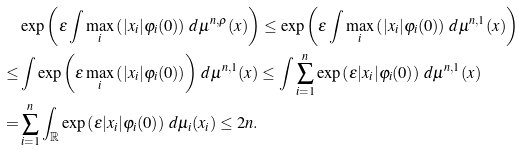Convert formula to latex. <formula><loc_0><loc_0><loc_500><loc_500>& \exp \left ( \varepsilon \int \max _ { i } \left ( | x _ { i } | \varphi _ { i } ( 0 ) \right ) \, d \mu ^ { n , \rho } ( x ) \right ) \leq \exp \left ( \varepsilon \int \max _ { i } \left ( | x _ { i } | \varphi _ { i } ( 0 ) \right ) \, d \mu ^ { n , 1 } ( x ) \right ) \\ \leq & \int \exp \left ( \varepsilon \max _ { i } \left ( | x _ { i } | \varphi _ { i } ( 0 ) \right ) \right ) \, d \mu ^ { n , 1 } ( x ) \leq \int \sum _ { i = 1 } ^ { n } \exp \left ( \varepsilon | x _ { i } | \varphi _ { i } ( 0 ) \right ) \, d \mu ^ { n , 1 } ( x ) \\ = & \sum _ { i = 1 } ^ { n } \int _ { \mathbb { R } } \exp \left ( \varepsilon | x _ { i } | \varphi _ { i } ( 0 ) \right ) \, d \mu _ { i } ( x _ { i } ) \leq 2 n .</formula> 